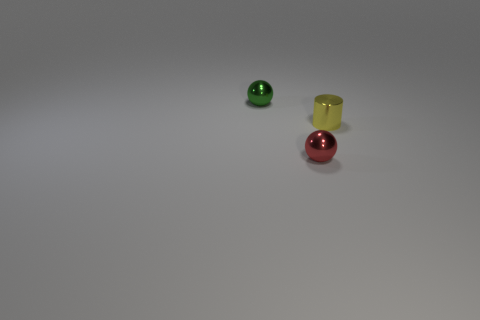Subtract all brown cylinders. Subtract all red balls. How many cylinders are left? 1 Add 3 yellow objects. How many objects exist? 6 Subtract all cylinders. How many objects are left? 2 Subtract 0 purple blocks. How many objects are left? 3 Subtract all big gray rubber cylinders. Subtract all metal cylinders. How many objects are left? 2 Add 1 small green shiny things. How many small green shiny things are left? 2 Add 2 yellow things. How many yellow things exist? 3 